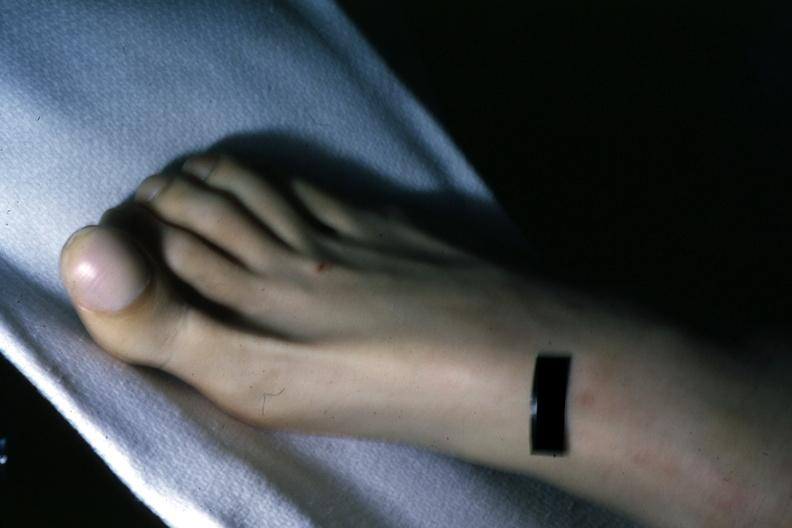what are present?
Answer the question using a single word or phrase. Extremities 